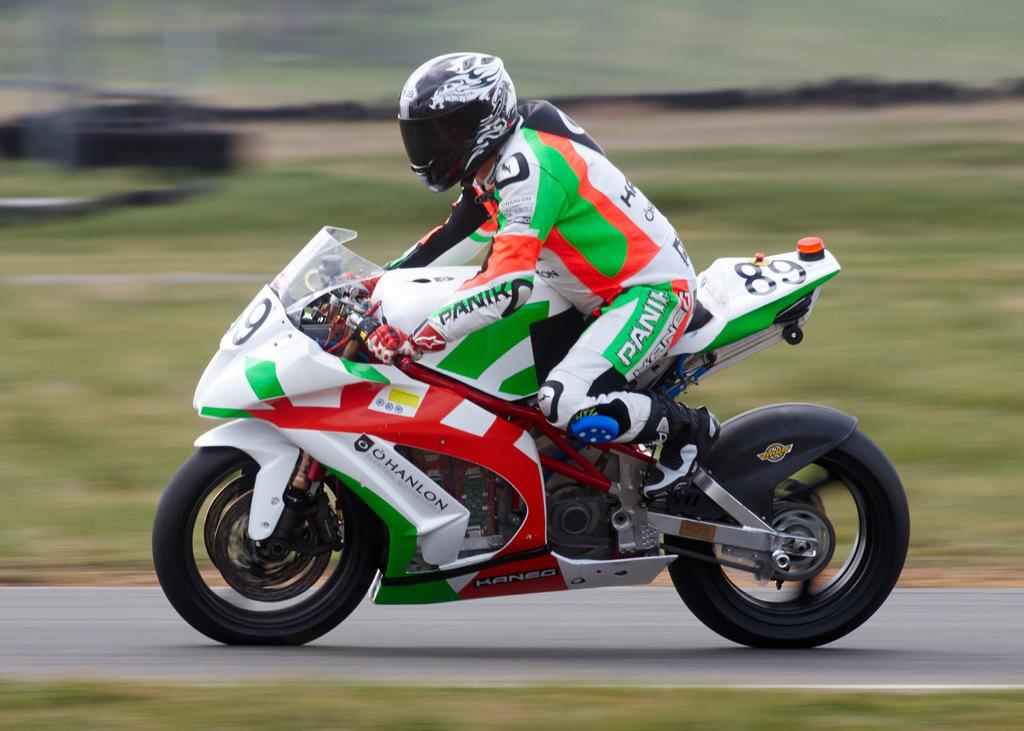What is the main subject of the image? There is a person in the image. What is the person doing in the image? The person is riding a bike. What can be seen beneath the person in the image? The ground is visible in the image. How would you describe the background of the image? The background of the image is blurred. How many rings can be seen on the rat's tail in the image? There is no rat present in the image, and therefore no rings on its tail can be observed. 